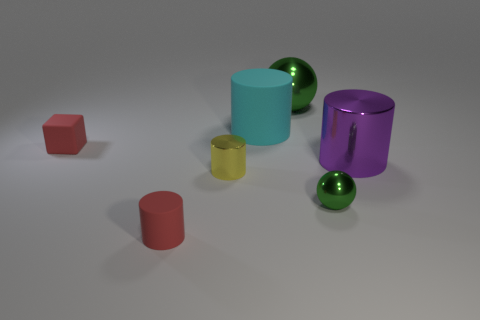There is a thing that is the same color as the tiny rubber cylinder; what is its size?
Keep it short and to the point. Small. Does the shiny cylinder behind the yellow thing have the same size as the red block?
Your answer should be compact. No. How many other things are there of the same size as the cyan rubber cylinder?
Make the answer very short. 2. Is the green sphere behind the purple cylinder made of the same material as the green object that is in front of the large green metallic thing?
Keep it short and to the point. Yes. The shiny ball that is the same size as the purple cylinder is what color?
Provide a succinct answer. Green. Is there anything else of the same color as the large metallic cylinder?
Your answer should be very brief. No. There is a matte cylinder that is behind the large metal thing to the right of the green metal sphere behind the red cube; how big is it?
Your response must be concise. Large. What color is the large object that is on the right side of the large matte cylinder and in front of the large shiny ball?
Provide a short and direct response. Purple. How big is the green thing in front of the cyan matte cylinder?
Give a very brief answer. Small. What number of large purple things have the same material as the small red block?
Your response must be concise. 0. 